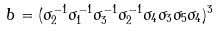Convert formula to latex. <formula><loc_0><loc_0><loc_500><loc_500>b = ( \sigma _ { 2 } ^ { - 1 } \sigma _ { 1 } ^ { - 1 } \sigma _ { 3 } ^ { - 1 } \sigma _ { 2 } ^ { - 1 } \sigma _ { 4 } \sigma _ { 3 } \sigma _ { 5 } \sigma _ { 4 } ) ^ { 3 }</formula> 